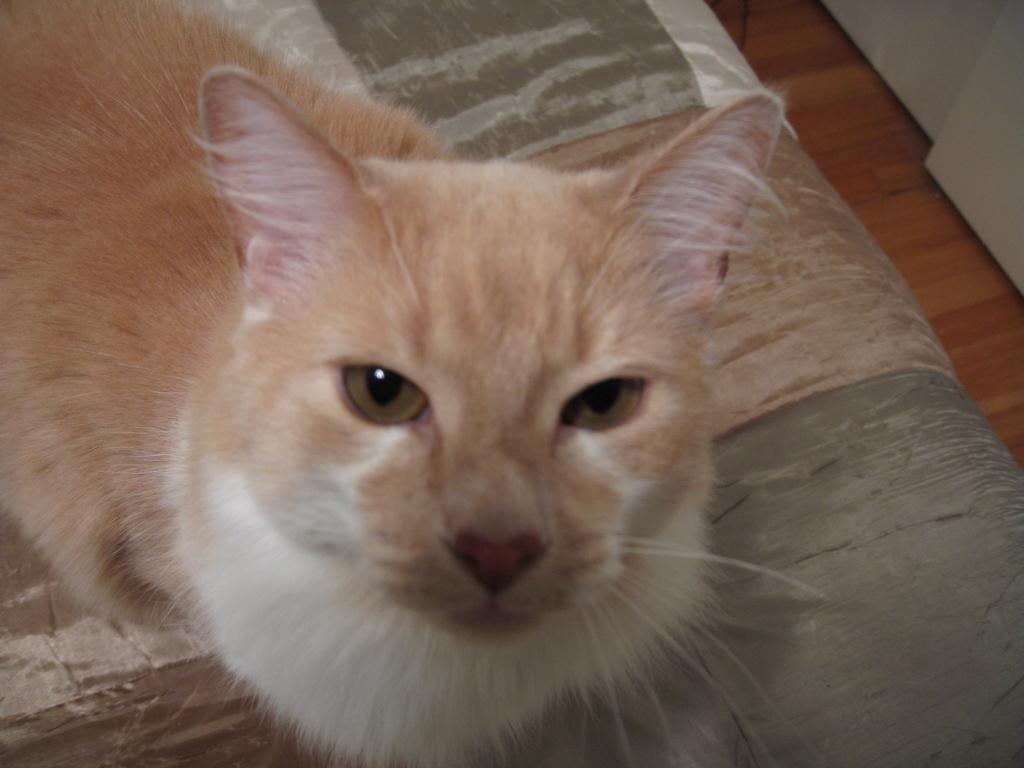What animal is in the picture? There is a cat in the picture. Where is the cat located in the image? The cat is standing on a bed. What type of flooring is visible under the bed? The bed is on a wooden floor. What color is the cat? The cat is cream in color. What part of the cat is white? There is a white part under the cat. What advice does the cat's mom give in the image? There is no indication in the image that the cat has a mom, nor is there any conversation or advice being given. 